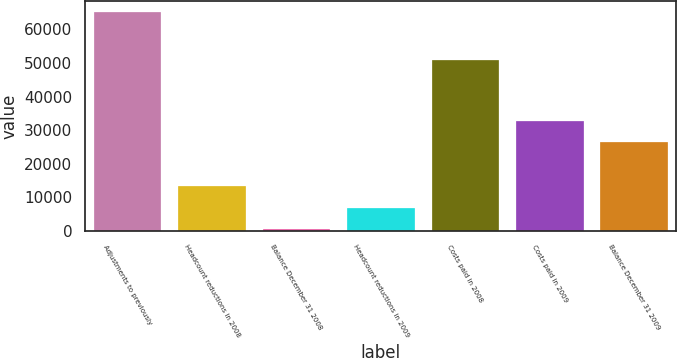<chart> <loc_0><loc_0><loc_500><loc_500><bar_chart><fcel>Adjustments to previously<fcel>Headcount reductions in 2008<fcel>Balance December 31 2008<fcel>Headcount reductions in 2009<fcel>Costs paid in 2008<fcel>Costs paid in 2009<fcel>Balance December 31 2009<nl><fcel>65152<fcel>13390.4<fcel>450<fcel>6920.2<fcel>50856<fcel>32801<fcel>26330.8<nl></chart> 